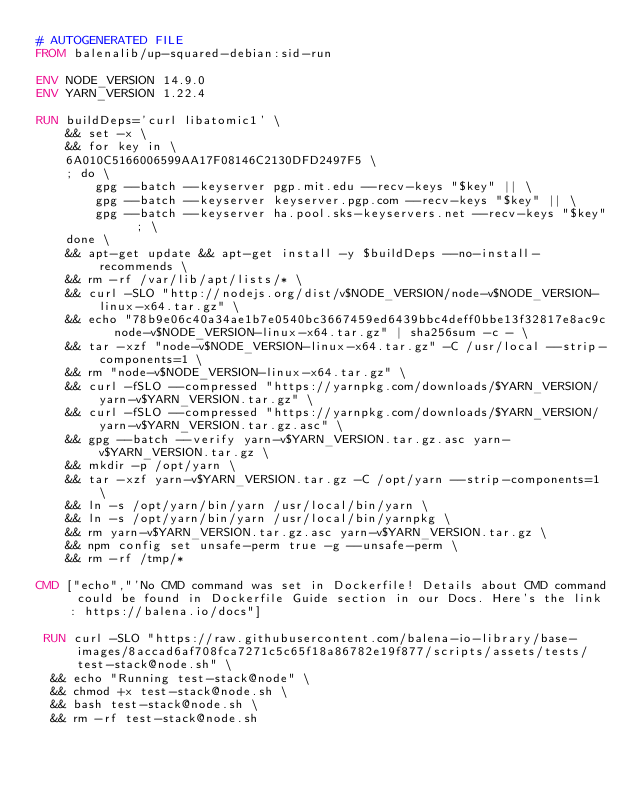Convert code to text. <code><loc_0><loc_0><loc_500><loc_500><_Dockerfile_># AUTOGENERATED FILE
FROM balenalib/up-squared-debian:sid-run

ENV NODE_VERSION 14.9.0
ENV YARN_VERSION 1.22.4

RUN buildDeps='curl libatomic1' \
	&& set -x \
	&& for key in \
	6A010C5166006599AA17F08146C2130DFD2497F5 \
	; do \
		gpg --batch --keyserver pgp.mit.edu --recv-keys "$key" || \
		gpg --batch --keyserver keyserver.pgp.com --recv-keys "$key" || \
		gpg --batch --keyserver ha.pool.sks-keyservers.net --recv-keys "$key" ; \
	done \
	&& apt-get update && apt-get install -y $buildDeps --no-install-recommends \
	&& rm -rf /var/lib/apt/lists/* \
	&& curl -SLO "http://nodejs.org/dist/v$NODE_VERSION/node-v$NODE_VERSION-linux-x64.tar.gz" \
	&& echo "78b9e06c40a34ae1b7e0540bc3667459ed6439bbc4deff0bbe13f32817e8ac9c  node-v$NODE_VERSION-linux-x64.tar.gz" | sha256sum -c - \
	&& tar -xzf "node-v$NODE_VERSION-linux-x64.tar.gz" -C /usr/local --strip-components=1 \
	&& rm "node-v$NODE_VERSION-linux-x64.tar.gz" \
	&& curl -fSLO --compressed "https://yarnpkg.com/downloads/$YARN_VERSION/yarn-v$YARN_VERSION.tar.gz" \
	&& curl -fSLO --compressed "https://yarnpkg.com/downloads/$YARN_VERSION/yarn-v$YARN_VERSION.tar.gz.asc" \
	&& gpg --batch --verify yarn-v$YARN_VERSION.tar.gz.asc yarn-v$YARN_VERSION.tar.gz \
	&& mkdir -p /opt/yarn \
	&& tar -xzf yarn-v$YARN_VERSION.tar.gz -C /opt/yarn --strip-components=1 \
	&& ln -s /opt/yarn/bin/yarn /usr/local/bin/yarn \
	&& ln -s /opt/yarn/bin/yarn /usr/local/bin/yarnpkg \
	&& rm yarn-v$YARN_VERSION.tar.gz.asc yarn-v$YARN_VERSION.tar.gz \
	&& npm config set unsafe-perm true -g --unsafe-perm \
	&& rm -rf /tmp/*

CMD ["echo","'No CMD command was set in Dockerfile! Details about CMD command could be found in Dockerfile Guide section in our Docs. Here's the link: https://balena.io/docs"]

 RUN curl -SLO "https://raw.githubusercontent.com/balena-io-library/base-images/8accad6af708fca7271c5c65f18a86782e19f877/scripts/assets/tests/test-stack@node.sh" \
  && echo "Running test-stack@node" \
  && chmod +x test-stack@node.sh \
  && bash test-stack@node.sh \
  && rm -rf test-stack@node.sh 
</code> 